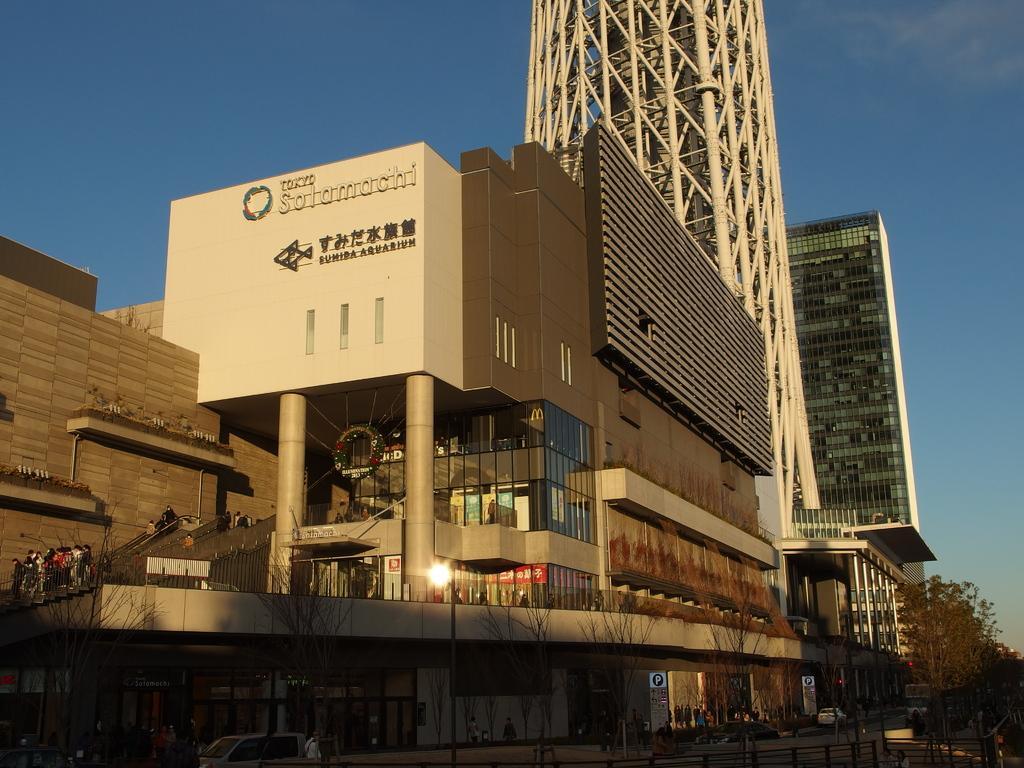Could you give a brief overview of what you see in this image? In this picture we can see buildings, trees, fence, vehicles and a group of people on the ground and steps and in the background we can see the sky. 